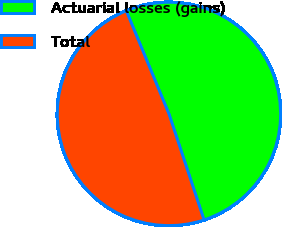Convert chart to OTSL. <chart><loc_0><loc_0><loc_500><loc_500><pie_chart><fcel>Actuarial losses (gains)<fcel>Total<nl><fcel>51.16%<fcel>48.84%<nl></chart> 